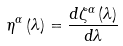<formula> <loc_0><loc_0><loc_500><loc_500>\eta ^ { \alpha } \left ( \lambda \right ) = \frac { d \zeta ^ { \alpha } \left ( \lambda \right ) } { d \lambda }</formula> 